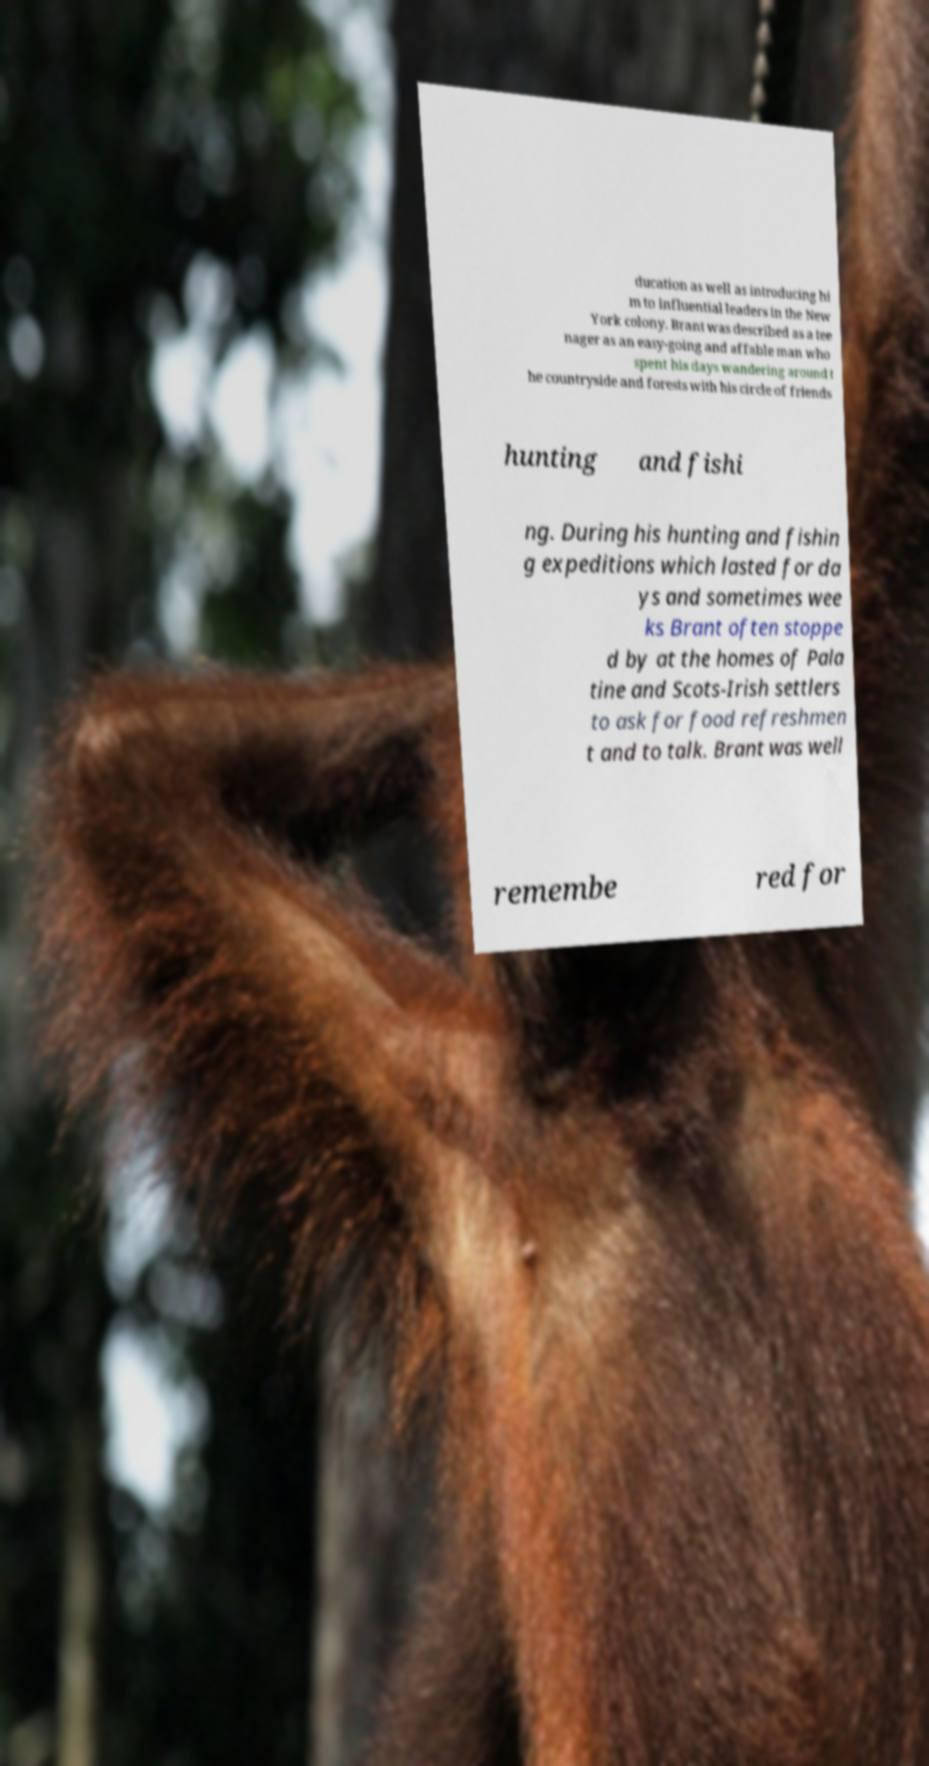Please identify and transcribe the text found in this image. ducation as well as introducing hi m to influential leaders in the New York colony. Brant was described as a tee nager as an easy-going and affable man who spent his days wandering around t he countryside and forests with his circle of friends hunting and fishi ng. During his hunting and fishin g expeditions which lasted for da ys and sometimes wee ks Brant often stoppe d by at the homes of Pala tine and Scots-Irish settlers to ask for food refreshmen t and to talk. Brant was well remembe red for 